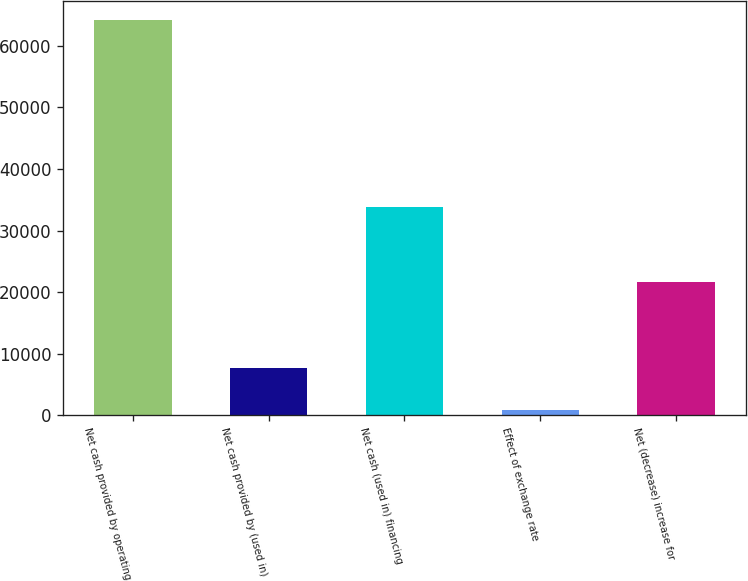<chart> <loc_0><loc_0><loc_500><loc_500><bar_chart><fcel>Net cash provided by operating<fcel>Net cash provided by (used in)<fcel>Net cash (used in) financing<fcel>Effect of exchange rate<fcel>Net (decrease) increase for<nl><fcel>64146<fcel>7720<fcel>33849<fcel>924<fcel>21653<nl></chart> 